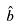<formula> <loc_0><loc_0><loc_500><loc_500>\hat { b }</formula> 